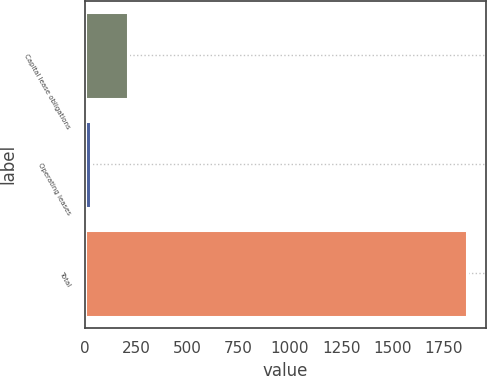Convert chart. <chart><loc_0><loc_0><loc_500><loc_500><bar_chart><fcel>Capital lease obligations<fcel>Operating leases<fcel>Total<nl><fcel>213.1<fcel>30<fcel>1861<nl></chart> 